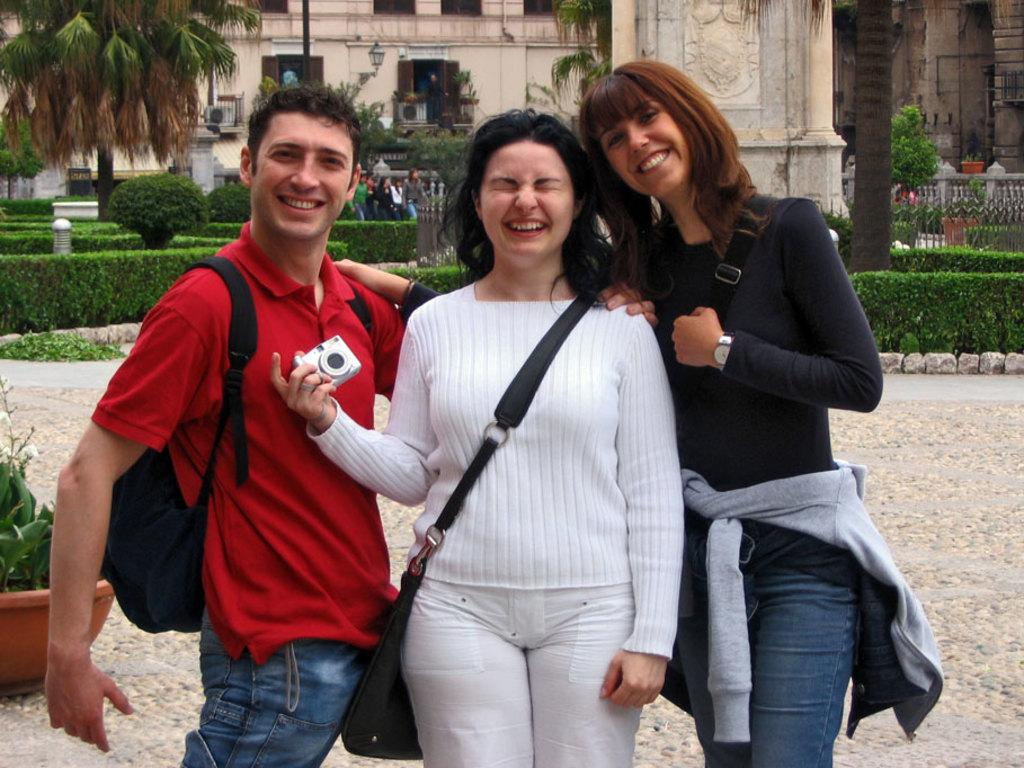How many people are in the image? There are three persons in the image. What are the persons doing in the image? The persons are standing and smiling. What can be seen in the background of the image? There are trees and buildings in the background of the image. What type of polish is being applied to the person's mouth in the image? There is no polish or any indication of applying it in the image. What kind of silk material is draped over the person's shoulder in the image? There is no silk material or any indication of it in the image. 